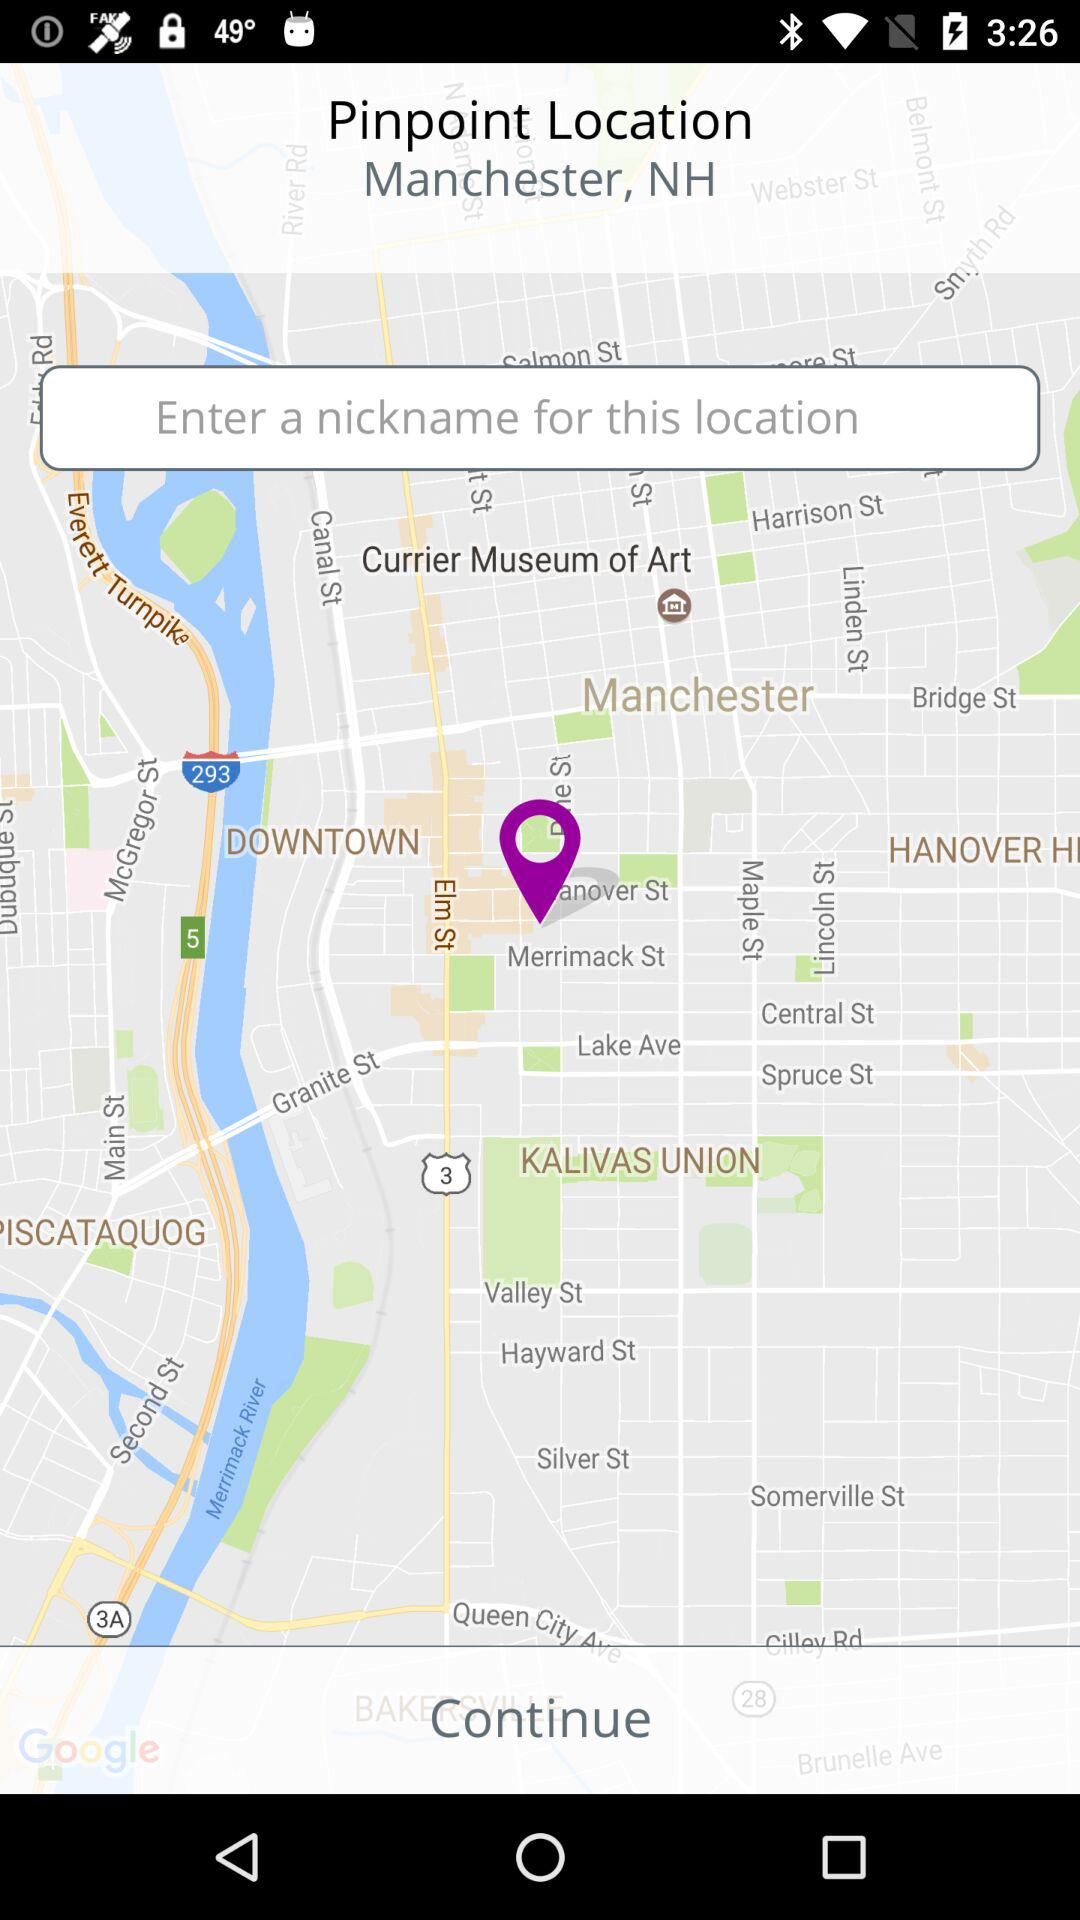What is the pinpoint location? The pinpoint location is Manchester, NH. 